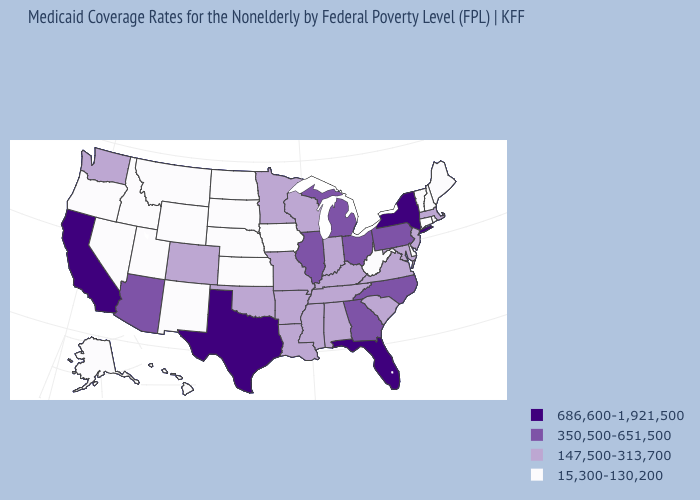Name the states that have a value in the range 15,300-130,200?
Give a very brief answer. Alaska, Connecticut, Delaware, Hawaii, Idaho, Iowa, Kansas, Maine, Montana, Nebraska, Nevada, New Hampshire, New Mexico, North Dakota, Oregon, Rhode Island, South Dakota, Utah, Vermont, West Virginia, Wyoming. Does New Jersey have a higher value than West Virginia?
Keep it brief. Yes. Name the states that have a value in the range 350,500-651,500?
Keep it brief. Arizona, Georgia, Illinois, Michigan, North Carolina, Ohio, Pennsylvania. What is the value of Massachusetts?
Write a very short answer. 147,500-313,700. Does Massachusetts have the highest value in the USA?
Answer briefly. No. What is the lowest value in the USA?
Short answer required. 15,300-130,200. Does Rhode Island have the lowest value in the USA?
Write a very short answer. Yes. Name the states that have a value in the range 147,500-313,700?
Be succinct. Alabama, Arkansas, Colorado, Indiana, Kentucky, Louisiana, Maryland, Massachusetts, Minnesota, Mississippi, Missouri, New Jersey, Oklahoma, South Carolina, Tennessee, Virginia, Washington, Wisconsin. Name the states that have a value in the range 15,300-130,200?
Concise answer only. Alaska, Connecticut, Delaware, Hawaii, Idaho, Iowa, Kansas, Maine, Montana, Nebraska, Nevada, New Hampshire, New Mexico, North Dakota, Oregon, Rhode Island, South Dakota, Utah, Vermont, West Virginia, Wyoming. Name the states that have a value in the range 15,300-130,200?
Keep it brief. Alaska, Connecticut, Delaware, Hawaii, Idaho, Iowa, Kansas, Maine, Montana, Nebraska, Nevada, New Hampshire, New Mexico, North Dakota, Oregon, Rhode Island, South Dakota, Utah, Vermont, West Virginia, Wyoming. What is the value of South Carolina?
Concise answer only. 147,500-313,700. Among the states that border Pennsylvania , does Delaware have the lowest value?
Answer briefly. Yes. What is the value of Illinois?
Concise answer only. 350,500-651,500. Does the map have missing data?
Quick response, please. No. 